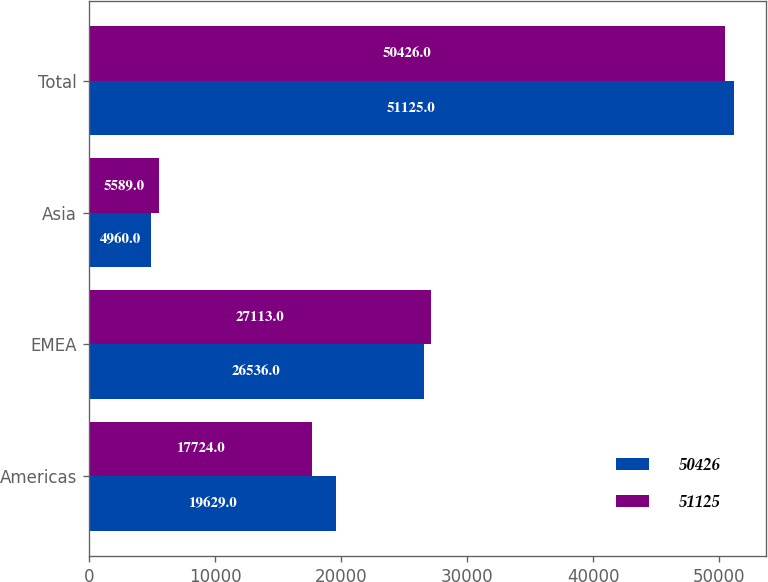<chart> <loc_0><loc_0><loc_500><loc_500><stacked_bar_chart><ecel><fcel>Americas<fcel>EMEA<fcel>Asia<fcel>Total<nl><fcel>50426<fcel>19629<fcel>26536<fcel>4960<fcel>51125<nl><fcel>51125<fcel>17724<fcel>27113<fcel>5589<fcel>50426<nl></chart> 